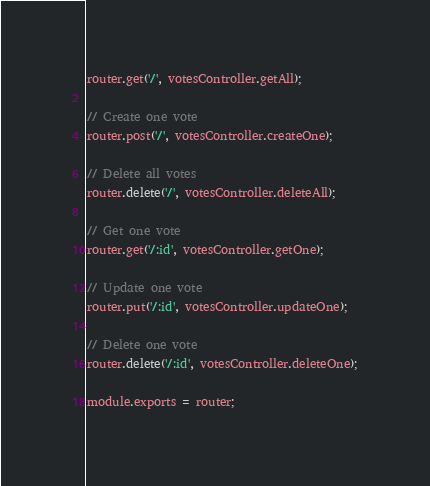<code> <loc_0><loc_0><loc_500><loc_500><_JavaScript_>router.get('/', votesController.getAll);

// Create one vote
router.post('/', votesController.createOne);

// Delete all votes
router.delete('/', votesController.deleteAll);

// Get one vote
router.get('/:id', votesController.getOne);

// Update one vote
router.put('/:id', votesController.updateOne);

// Delete one vote
router.delete('/:id', votesController.deleteOne);

module.exports = router;
</code> 